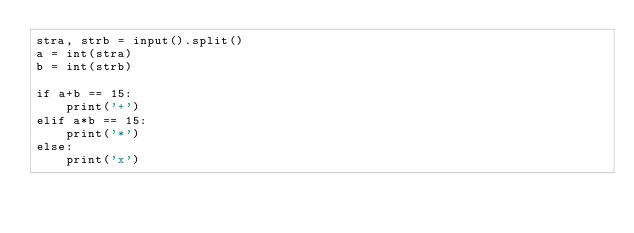<code> <loc_0><loc_0><loc_500><loc_500><_Python_>stra, strb = input().split()
a = int(stra)
b = int(strb)

if a+b == 15:
    print('+')
elif a*b == 15:
    print('*')
else:
    print('x')
</code> 